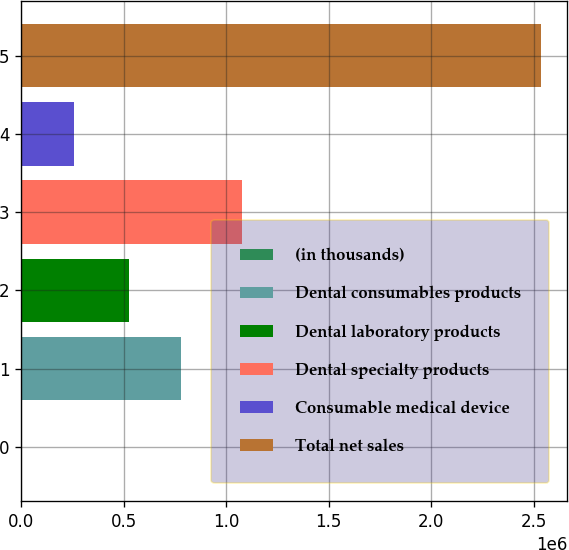Convert chart to OTSL. <chart><loc_0><loc_0><loc_500><loc_500><bar_chart><fcel>(in thousands)<fcel>Dental consumables products<fcel>Dental laboratory products<fcel>Dental specialty products<fcel>Consumable medical device<fcel>Total net sales<nl><fcel>2011<fcel>778579<fcel>525008<fcel>1.07803e+06<fcel>255582<fcel>2.53772e+06<nl></chart> 